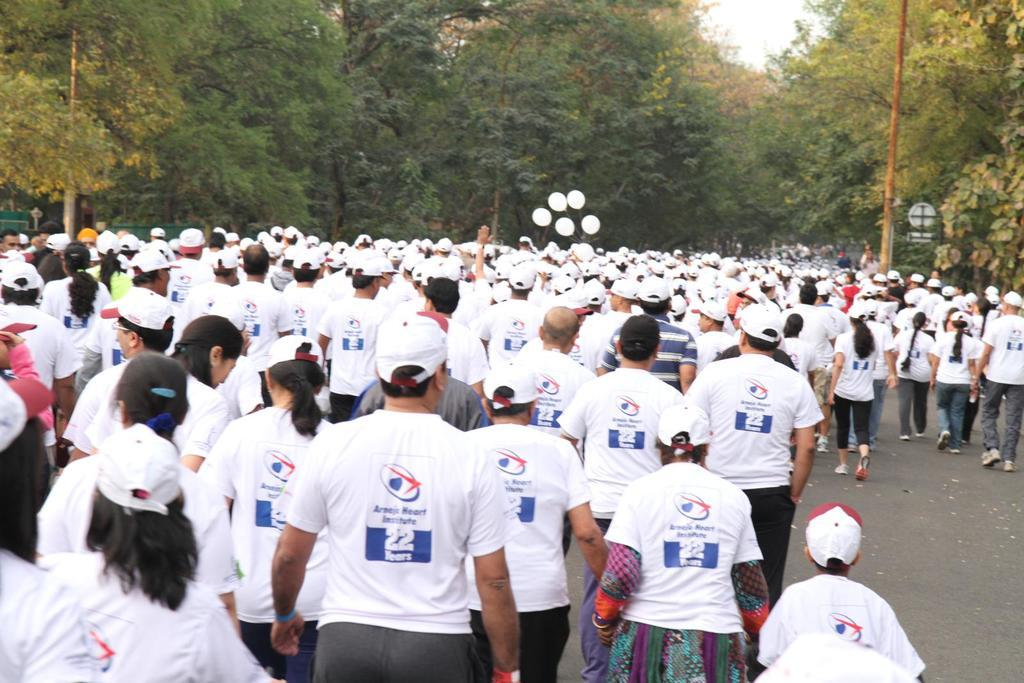How many people are in the group visible in the image? There is a group of people in the image, but the exact number is not specified. What are the people wearing in the image? The people are wearing white t-shirts in the image. What else can be seen in the image besides the group of people? There are balloons and trees visible in the image. What is visible in the background of the image? The sky is visible in the image. How many lizards are crawling on the trees in the image? There are no lizards visible in the image; only trees are mentioned. What type of credit is being offered to the people in the image? There is no mention of credit or any financial transaction in the image. 